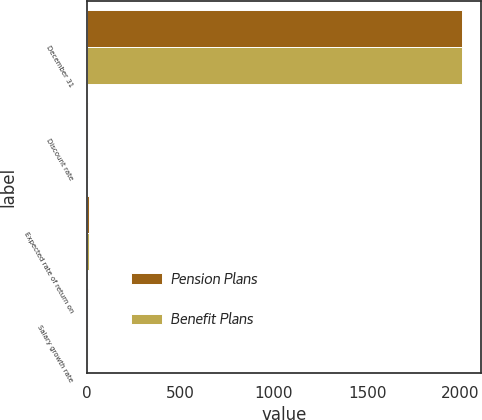<chart> <loc_0><loc_0><loc_500><loc_500><stacked_bar_chart><ecel><fcel>December 31<fcel>Discount rate<fcel>Expected rate of return on<fcel>Salary growth rate<nl><fcel>Pension Plans<fcel>2009<fcel>5.8<fcel>7.9<fcel>4.3<nl><fcel>Benefit Plans<fcel>2009<fcel>6.15<fcel>8.75<fcel>4.5<nl></chart> 